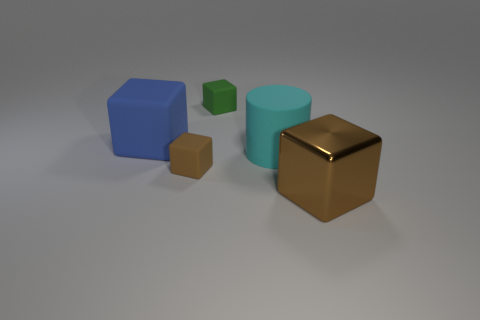There is a matte thing that is both in front of the green rubber thing and to the right of the tiny brown rubber cube; what color is it?
Give a very brief answer. Cyan. Are there any tiny green objects?
Offer a very short reply. Yes. Are there the same number of tiny blocks in front of the blue matte thing and large matte cylinders?
Your answer should be very brief. Yes. How many other things are there of the same shape as the small brown rubber thing?
Provide a short and direct response. 3. What is the shape of the big cyan thing?
Keep it short and to the point. Cylinder. Does the blue object have the same material as the big cyan cylinder?
Ensure brevity in your answer.  Yes. Are there the same number of blue things that are in front of the large brown metallic object and green things that are on the right side of the small brown object?
Provide a succinct answer. No. Are there any things that are right of the tiny matte object that is behind the brown thing left of the big cylinder?
Your answer should be compact. Yes. Do the brown shiny object and the blue rubber block have the same size?
Give a very brief answer. Yes. There is a small object in front of the small green rubber block that is behind the brown block on the left side of the shiny block; what color is it?
Provide a short and direct response. Brown. 